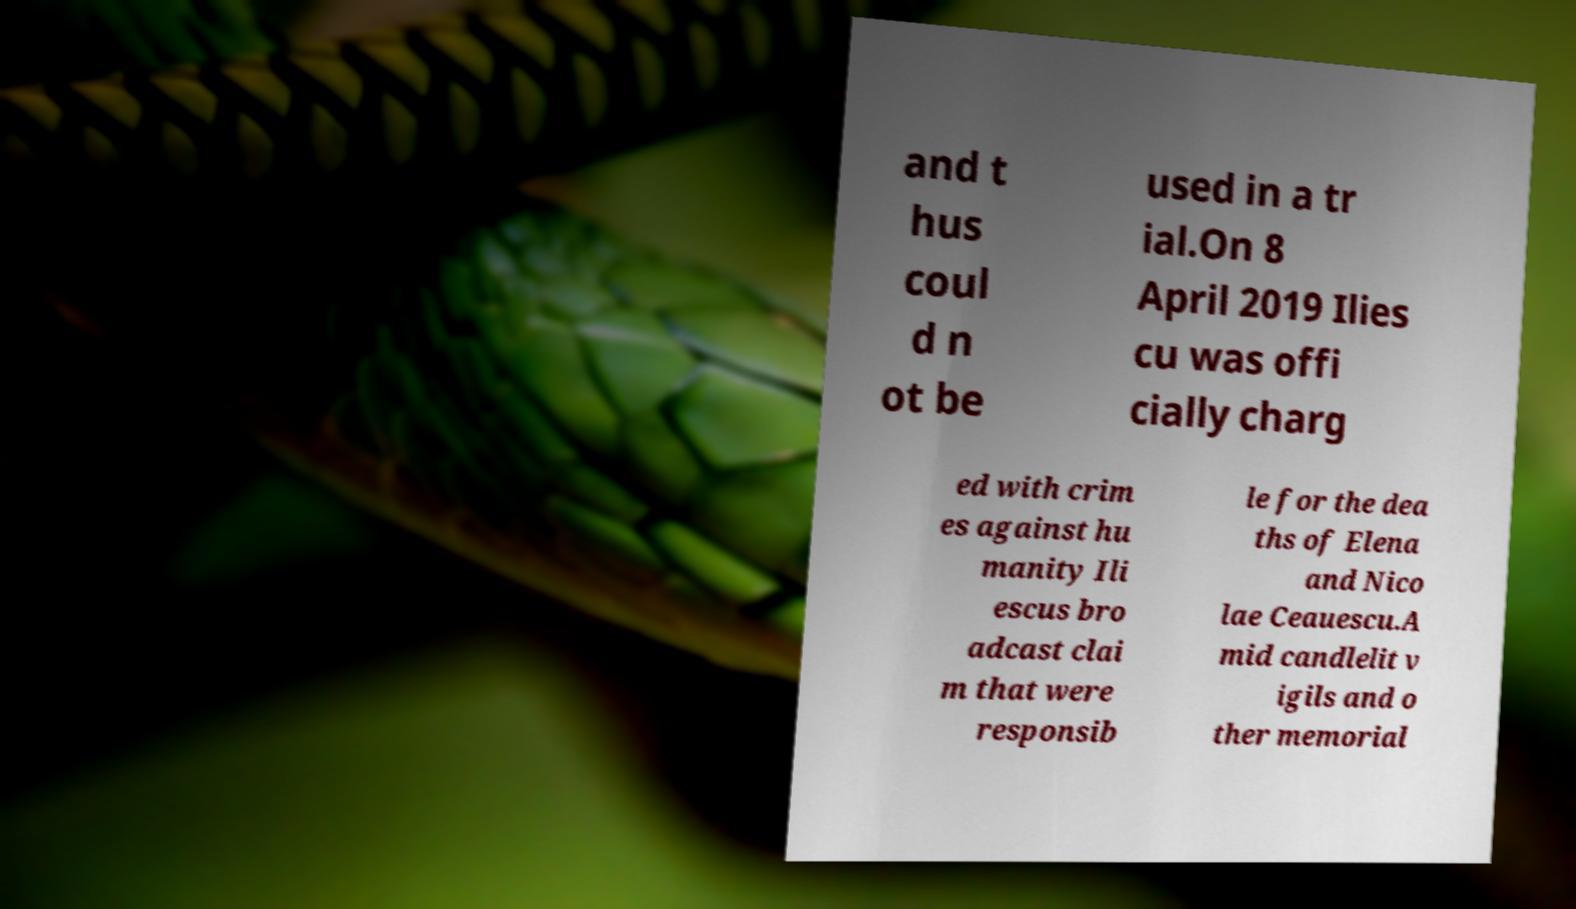Please read and relay the text visible in this image. What does it say? and t hus coul d n ot be used in a tr ial.On 8 April 2019 Ilies cu was offi cially charg ed with crim es against hu manity Ili escus bro adcast clai m that were responsib le for the dea ths of Elena and Nico lae Ceauescu.A mid candlelit v igils and o ther memorial 